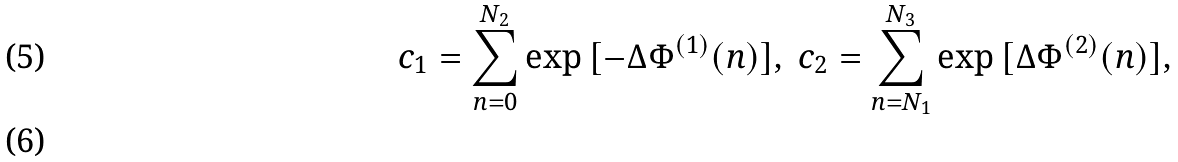Convert formula to latex. <formula><loc_0><loc_0><loc_500><loc_500>c _ { 1 } = \sum ^ { N _ { 2 } } _ { n = 0 } { \exp { [ - \Delta \Phi ^ { ( 1 ) } ( n ) ] } } , \ c _ { 2 } = \sum ^ { N _ { 3 } } _ { n = N _ { 1 } } { \exp { [ \Delta \Phi ^ { ( 2 ) } ( n ) ] } } , \\</formula> 